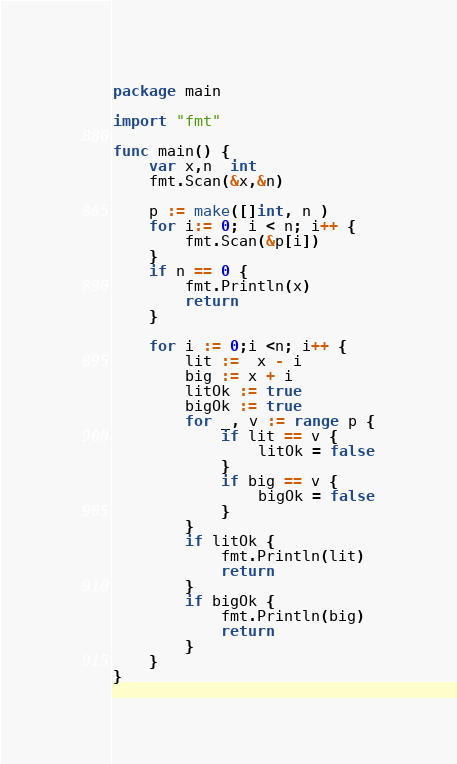Convert code to text. <code><loc_0><loc_0><loc_500><loc_500><_Go_>package main

import "fmt"

func main() {
	var x,n  int
	fmt.Scan(&x,&n)

	p := make([]int, n )
	for i:= 0; i < n; i++ {
		fmt.Scan(&p[i])
	}
	if n == 0 {
		fmt.Println(x)
		return
	}

	for i := 0;i <n; i++ {
		lit :=  x - i
		big := x + i
		litOk := true
		bigOk := true
		for _, v := range p {
			if lit == v {
				litOk = false
			}
			if big == v {
				bigOk = false
			}
		}
		if litOk {
			fmt.Println(lit)
			return
		}
		if bigOk {
			fmt.Println(big)
			return
		}
	}
}

</code> 